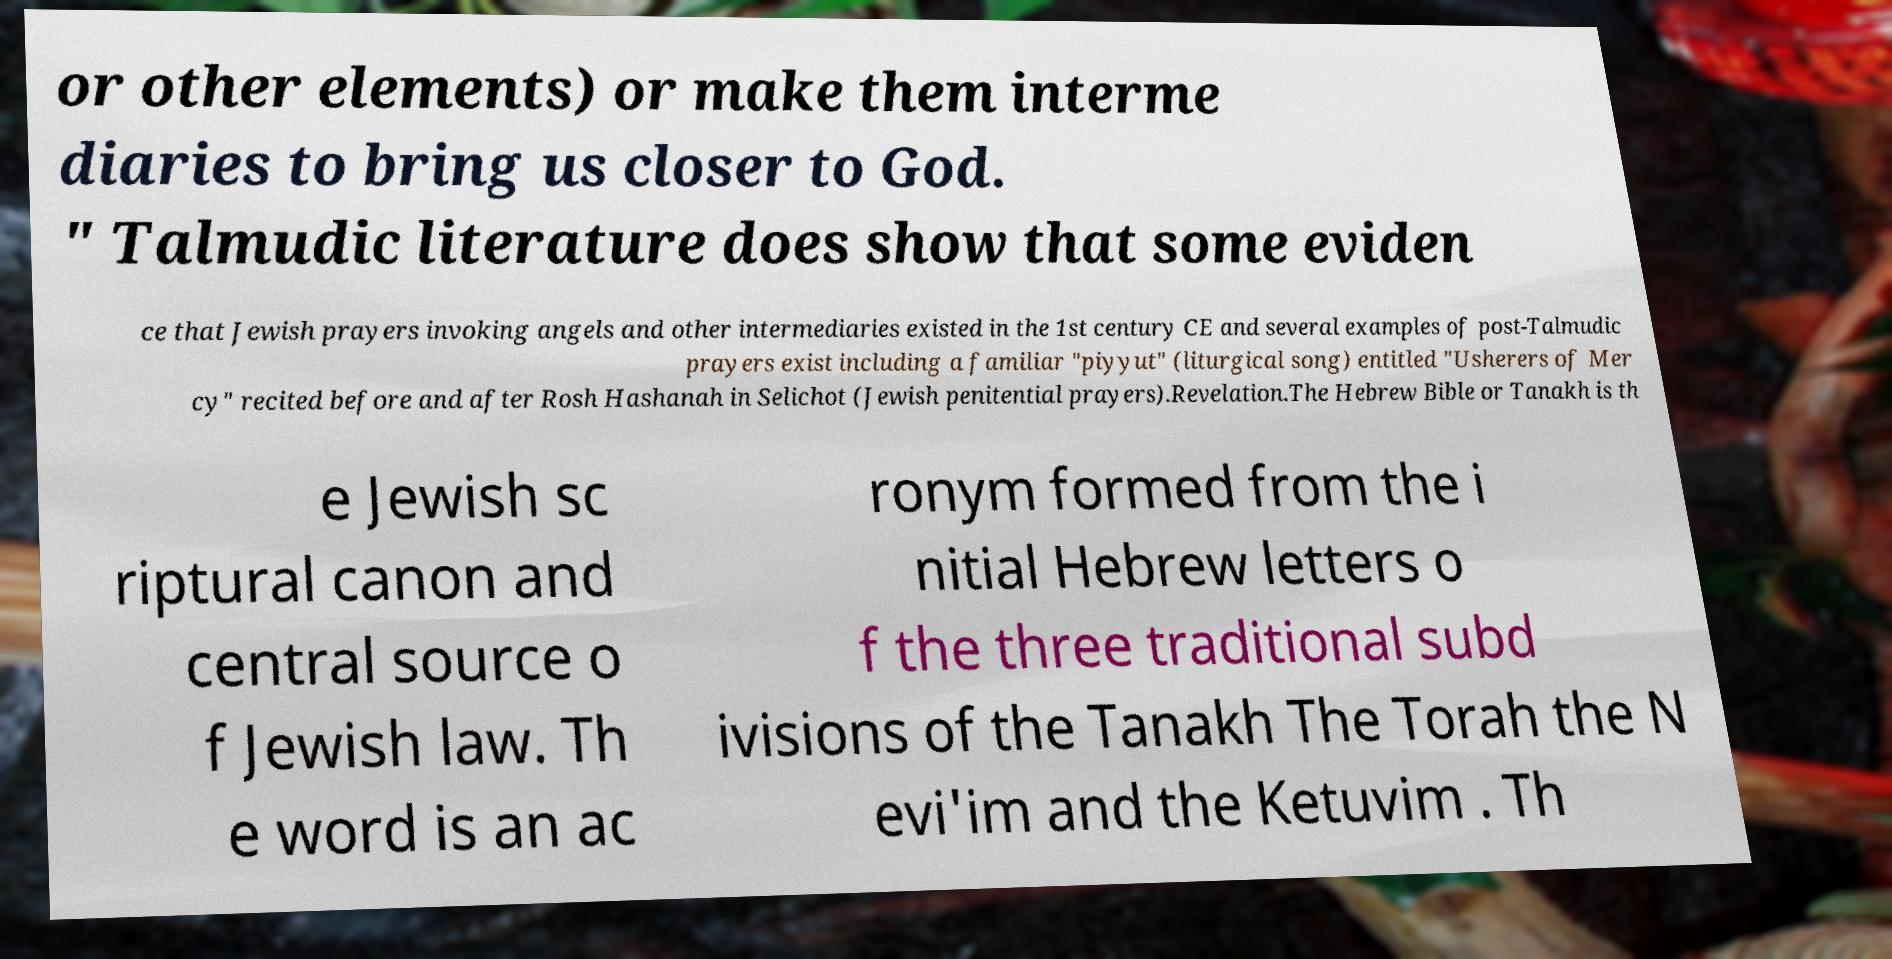Could you assist in decoding the text presented in this image and type it out clearly? or other elements) or make them interme diaries to bring us closer to God. " Talmudic literature does show that some eviden ce that Jewish prayers invoking angels and other intermediaries existed in the 1st century CE and several examples of post-Talmudic prayers exist including a familiar "piyyut" (liturgical song) entitled "Usherers of Mer cy" recited before and after Rosh Hashanah in Selichot (Jewish penitential prayers).Revelation.The Hebrew Bible or Tanakh is th e Jewish sc riptural canon and central source o f Jewish law. Th e word is an ac ronym formed from the i nitial Hebrew letters o f the three traditional subd ivisions of the Tanakh The Torah the N evi'im and the Ketuvim . Th 